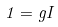<formula> <loc_0><loc_0><loc_500><loc_500>1 = g I</formula> 